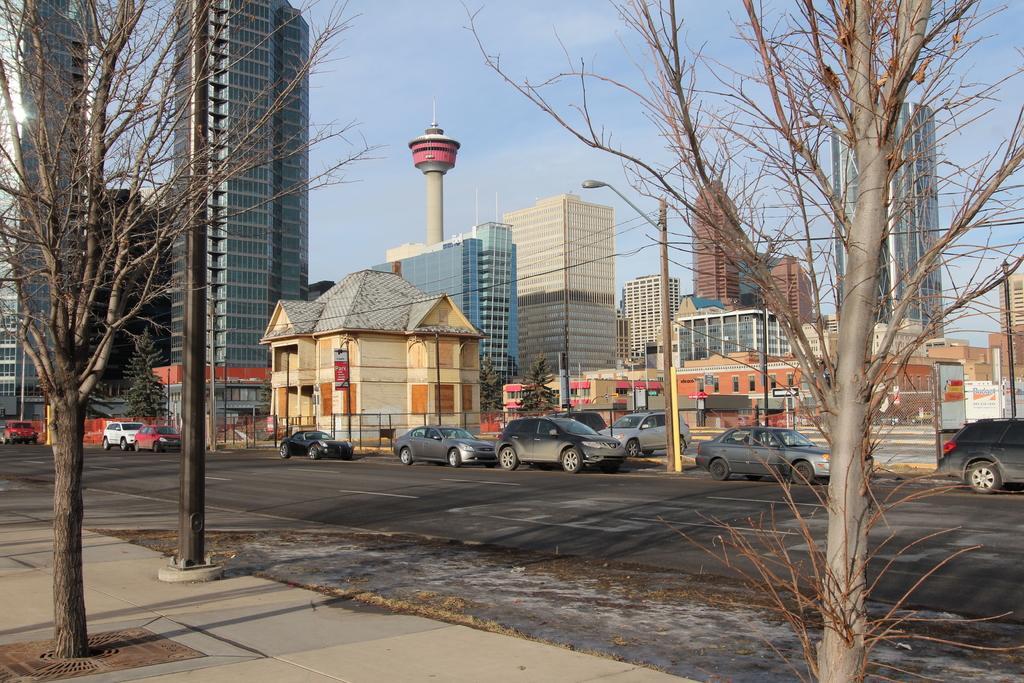Please provide a concise description of this image. In the foreground of the picture I can see the deciduous trees on the side of the road. I can see the cars on the road. In the background, I can see the tower buildings. I can see a light pole on the side of the road. There are clouds in the sky. 